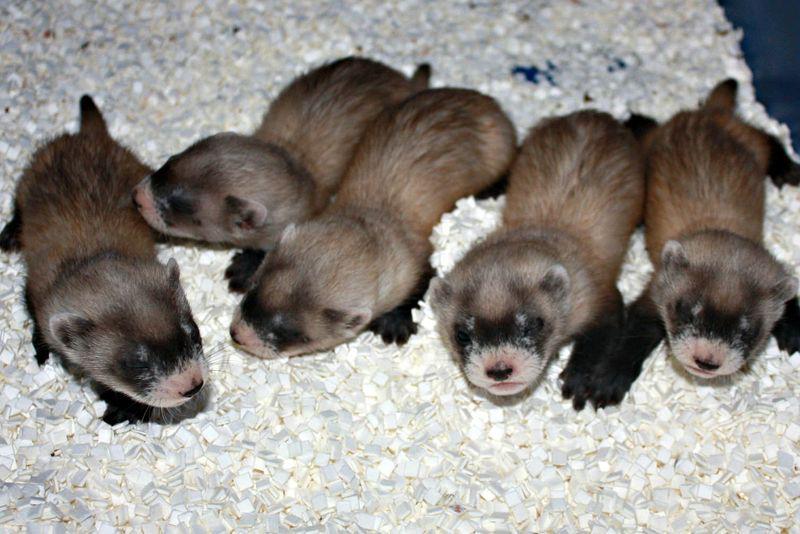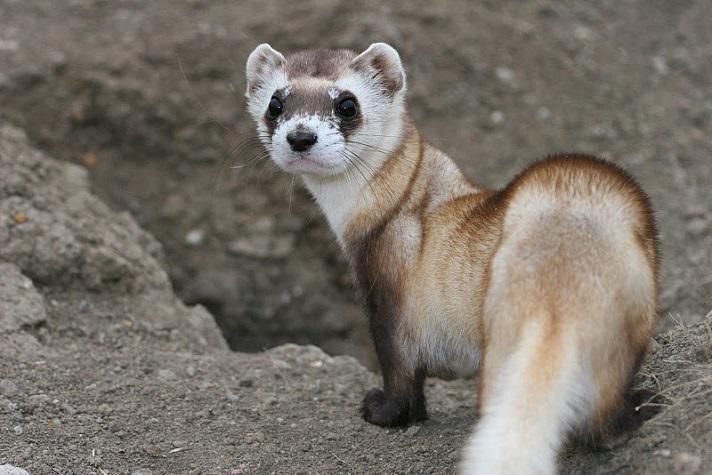The first image is the image on the left, the second image is the image on the right. Analyze the images presented: Is the assertion "An image contains a row of five ferrets." valid? Answer yes or no. Yes. The first image is the image on the left, the second image is the image on the right. Given the left and right images, does the statement "there are five animals in the image on the left" hold true? Answer yes or no. Yes. The first image is the image on the left, the second image is the image on the right. Assess this claim about the two images: "There are exactly five ferrets in the left image.". Correct or not? Answer yes or no. Yes. The first image is the image on the left, the second image is the image on the right. Analyze the images presented: Is the assertion "There are three ferrets" valid? Answer yes or no. No. 